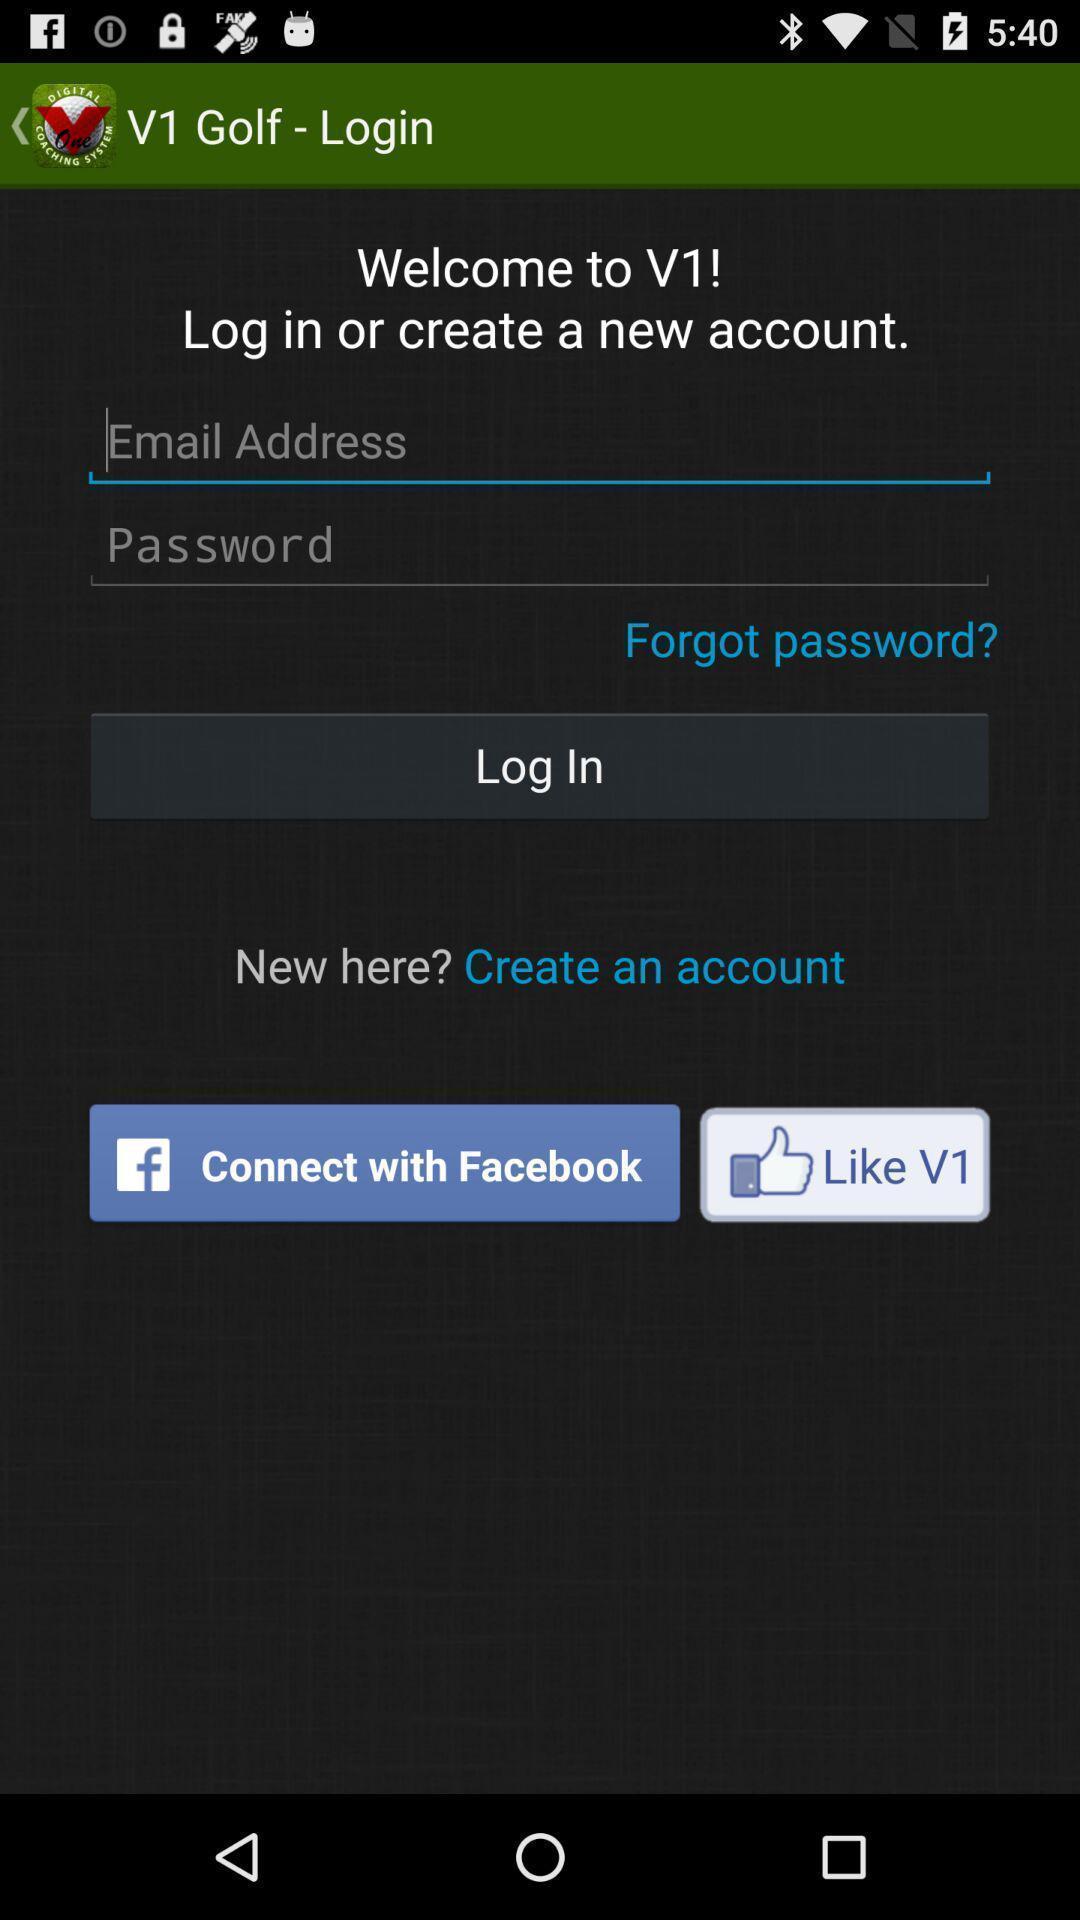Explain what's happening in this screen capture. Page for creation of account with social application. 